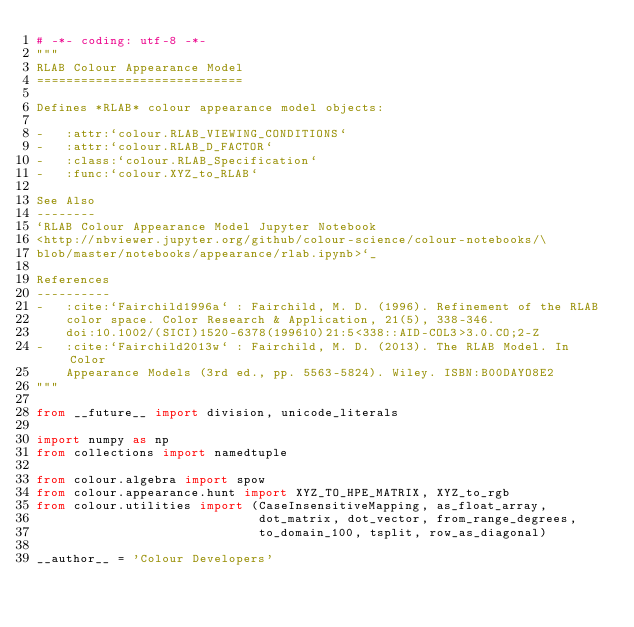<code> <loc_0><loc_0><loc_500><loc_500><_Python_># -*- coding: utf-8 -*-
"""
RLAB Colour Appearance Model
============================

Defines *RLAB* colour appearance model objects:

-   :attr:`colour.RLAB_VIEWING_CONDITIONS`
-   :attr:`colour.RLAB_D_FACTOR`
-   :class:`colour.RLAB_Specification`
-   :func:`colour.XYZ_to_RLAB`

See Also
--------
`RLAB Colour Appearance Model Jupyter Notebook
<http://nbviewer.jupyter.org/github/colour-science/colour-notebooks/\
blob/master/notebooks/appearance/rlab.ipynb>`_

References
----------
-   :cite:`Fairchild1996a` : Fairchild, M. D. (1996). Refinement of the RLAB
    color space. Color Research & Application, 21(5), 338-346.
    doi:10.1002/(SICI)1520-6378(199610)21:5<338::AID-COL3>3.0.CO;2-Z
-   :cite:`Fairchild2013w` : Fairchild, M. D. (2013). The RLAB Model. In Color
    Appearance Models (3rd ed., pp. 5563-5824). Wiley. ISBN:B00DAYO8E2
"""

from __future__ import division, unicode_literals

import numpy as np
from collections import namedtuple

from colour.algebra import spow
from colour.appearance.hunt import XYZ_TO_HPE_MATRIX, XYZ_to_rgb
from colour.utilities import (CaseInsensitiveMapping, as_float_array,
                              dot_matrix, dot_vector, from_range_degrees,
                              to_domain_100, tsplit, row_as_diagonal)

__author__ = 'Colour Developers'</code> 